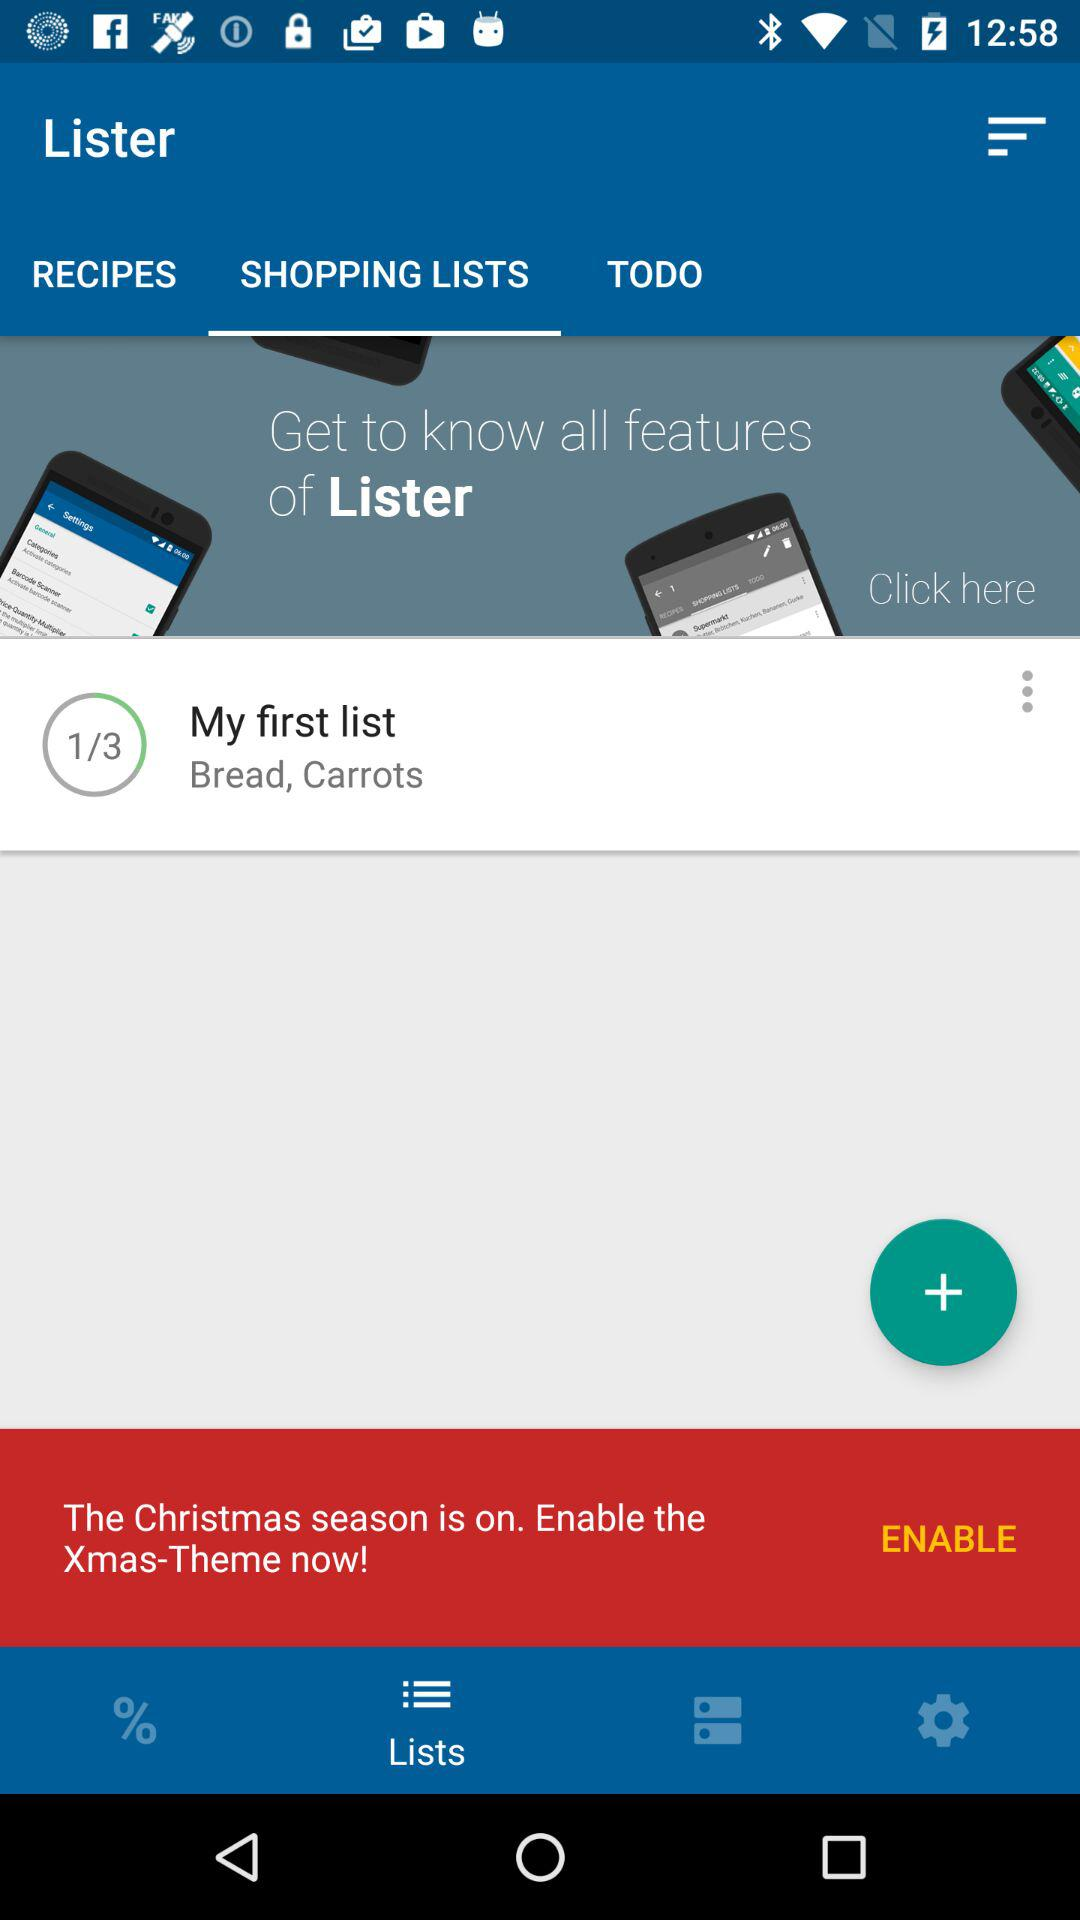Which tab is selected? The selected tabs are "SHOPPING LISTS" and "Lists". 